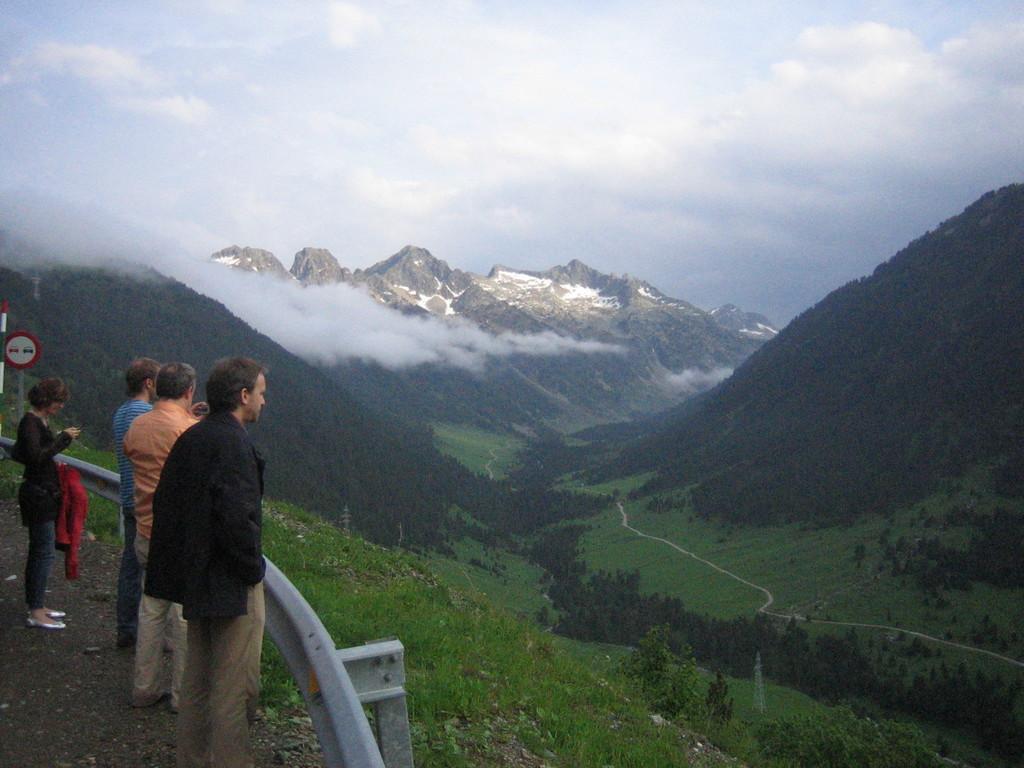Could you give a brief overview of what you see in this image? In this picture there are mountains and trees and there are towers. On the left side of the image there are group of people standing on the road and there is a railing on the road and there is a board on the pole. At the top there is sky and there are clouds. 